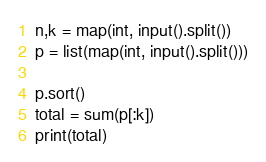<code> <loc_0><loc_0><loc_500><loc_500><_Python_>n,k = map(int, input().split())
p = list(map(int, input().split()))

p.sort()
total = sum(p[:k])
print(total)</code> 